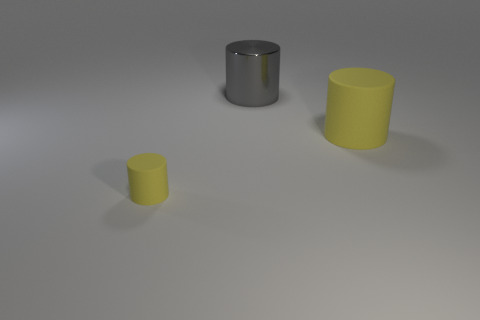Is there anything else that is the same material as the gray cylinder?
Provide a short and direct response. No. What is the size of the object that is right of the tiny yellow cylinder and in front of the large gray object?
Keep it short and to the point. Large. Is the number of large things right of the shiny cylinder greater than the number of big yellow rubber things that are to the right of the tiny yellow cylinder?
Your answer should be very brief. No. There is a thing that is the same color as the large rubber cylinder; what size is it?
Your response must be concise. Small. What is the color of the metal cylinder?
Make the answer very short. Gray. The cylinder that is both in front of the big gray object and behind the small matte object is what color?
Offer a very short reply. Yellow. The matte cylinder that is to the left of the rubber object behind the matte cylinder in front of the large yellow cylinder is what color?
Your answer should be very brief. Yellow. What is the color of the other cylinder that is the same size as the metallic cylinder?
Offer a terse response. Yellow. What shape is the matte object that is in front of the rubber object on the right side of the yellow rubber cylinder on the left side of the big matte cylinder?
Make the answer very short. Cylinder. What shape is the other thing that is the same color as the small rubber object?
Keep it short and to the point. Cylinder. 